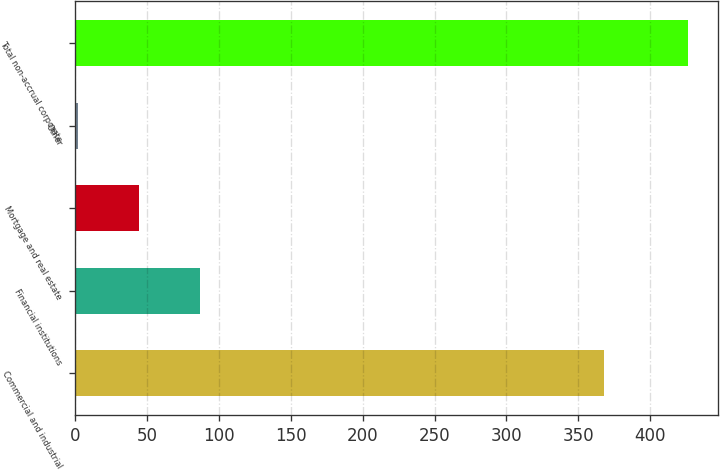<chart> <loc_0><loc_0><loc_500><loc_500><bar_chart><fcel>Commercial and industrial<fcel>Financial institutions<fcel>Mortgage and real estate<fcel>Other<fcel>Total non-accrual corporate<nl><fcel>368<fcel>86.8<fcel>44.4<fcel>2<fcel>426<nl></chart> 